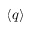<formula> <loc_0><loc_0><loc_500><loc_500>\langle q \rangle</formula> 